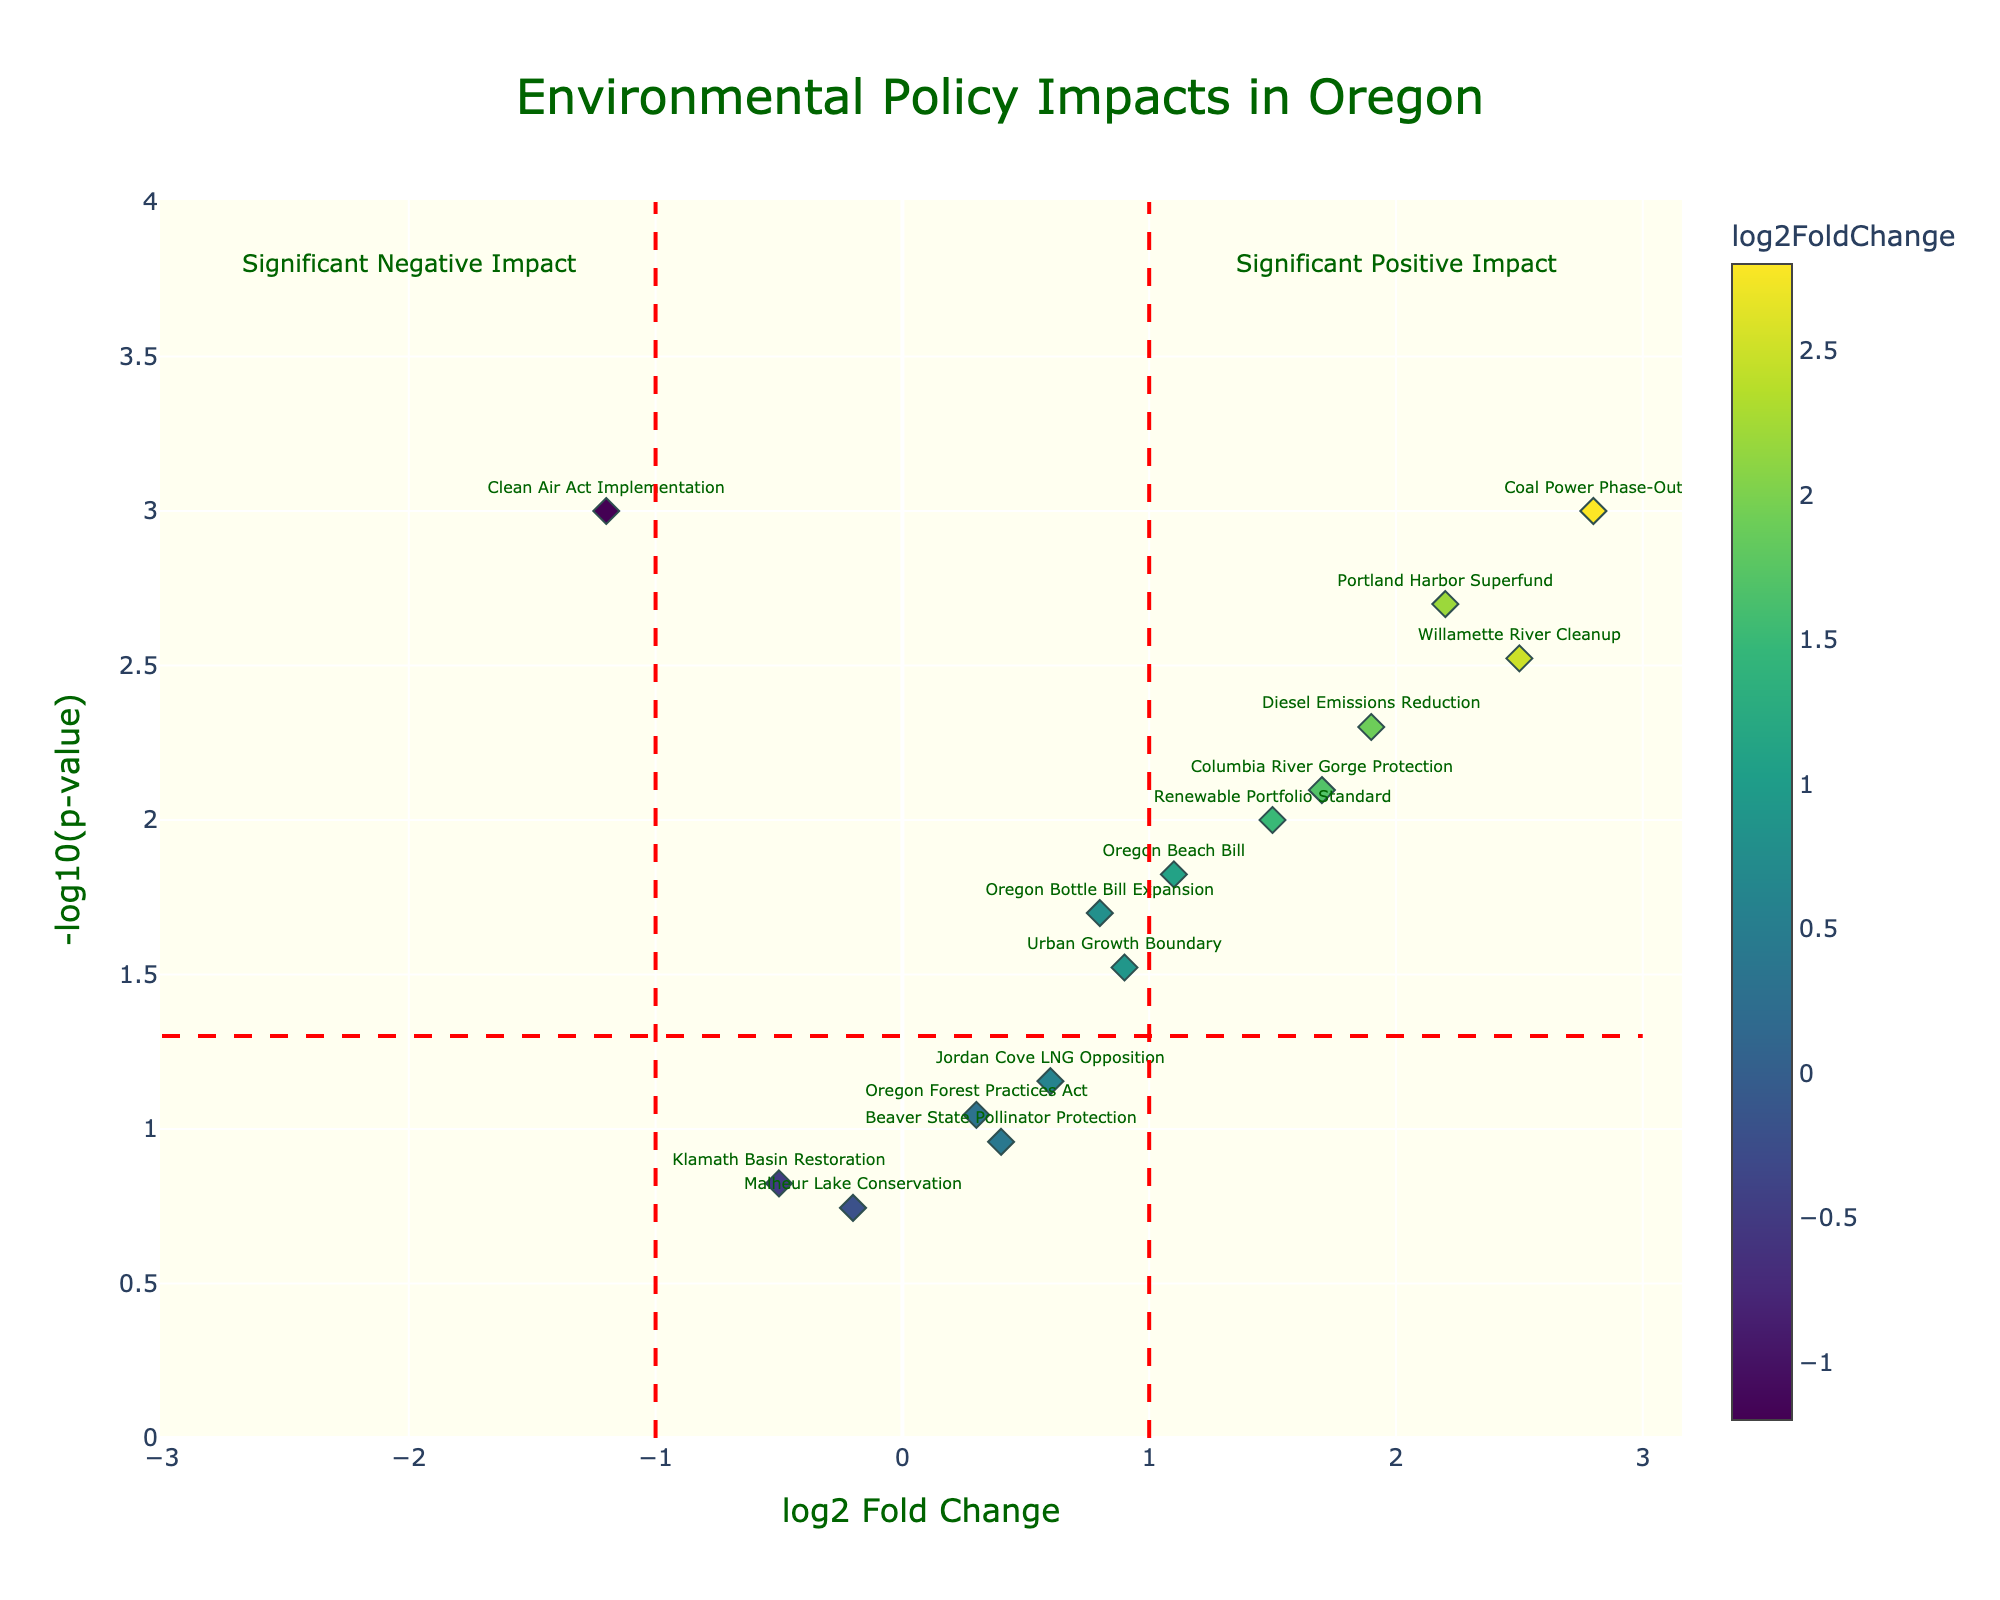How many policies have a significant impact according to the plot? As per the plot, significance is determined by the -log10(p-value) threshold greater than 1.3 (p-value < 0.05). Count the points above this threshold.
Answer: 12 Which policy shows the highest positive impact on log2FoldChange? Look for the point with the highest log2FoldChange value along the x-axis and check its label.
Answer: Coal Power Phase-Out What does a negative log2FoldChange indicate in this plot? In a volcano plot, negative log2FoldChange values typically represent a reduction or negative impact of the policy on the indicators.
Answer: Negative impact What is the range of -log10(p-value) in the plot? Identify the minimum and maximum values on the y-axis (-log10(p-value)). The range can be found from 0 to the highest label.
Answer: 0 to 3.8 Which policy has the most minimal impact according to the -log10(p-value) scale? Look for the point closest to the origin in terms of y-value and check its label.
Answer: Malheur Lake Conservation Compare the impact of the "Oregon Beach Bill" and the "Willamette River Cleanup" on air and water quality indicators. Locate the positions of both policies on the volcano plot. Compare their log2FoldChange and -log10(p-value) values. The "Oregon Beach Bill" is lower in both log2FoldChange and -log10(p-value) than the "Willamette River Cleanup".
Answer: Willamette River Cleanup has a higher impact What's the range of log2FoldChange values depicted in the plot? Identify the minimum and maximum values on the x-axis (log2FoldChange). The range is indicated from left to right.
Answer: -1.2 to 2.8 How does the "Renewable Portfolio Standard" policy compare to the "Urban Growth Boundary" in terms of significance and impact? Compare their positions in the plot by looking at their -log10(p-value) and log2FoldChange values. The "Renewable Portfolio Standard" has a higher -log10(p-value) and log2FoldChange.
Answer: Renewable Portfolio Standard is more significant and has a greater impact What's the general significance threshold indicated by the red dashed horizontal line? The red dashed horizontal line represents the significance threshold, which is based on -log10(p-value). Typically, this line corresponds to a p-value of 0.05, making -log10(0.05) approximately 1.3.
Answer: 1.3 